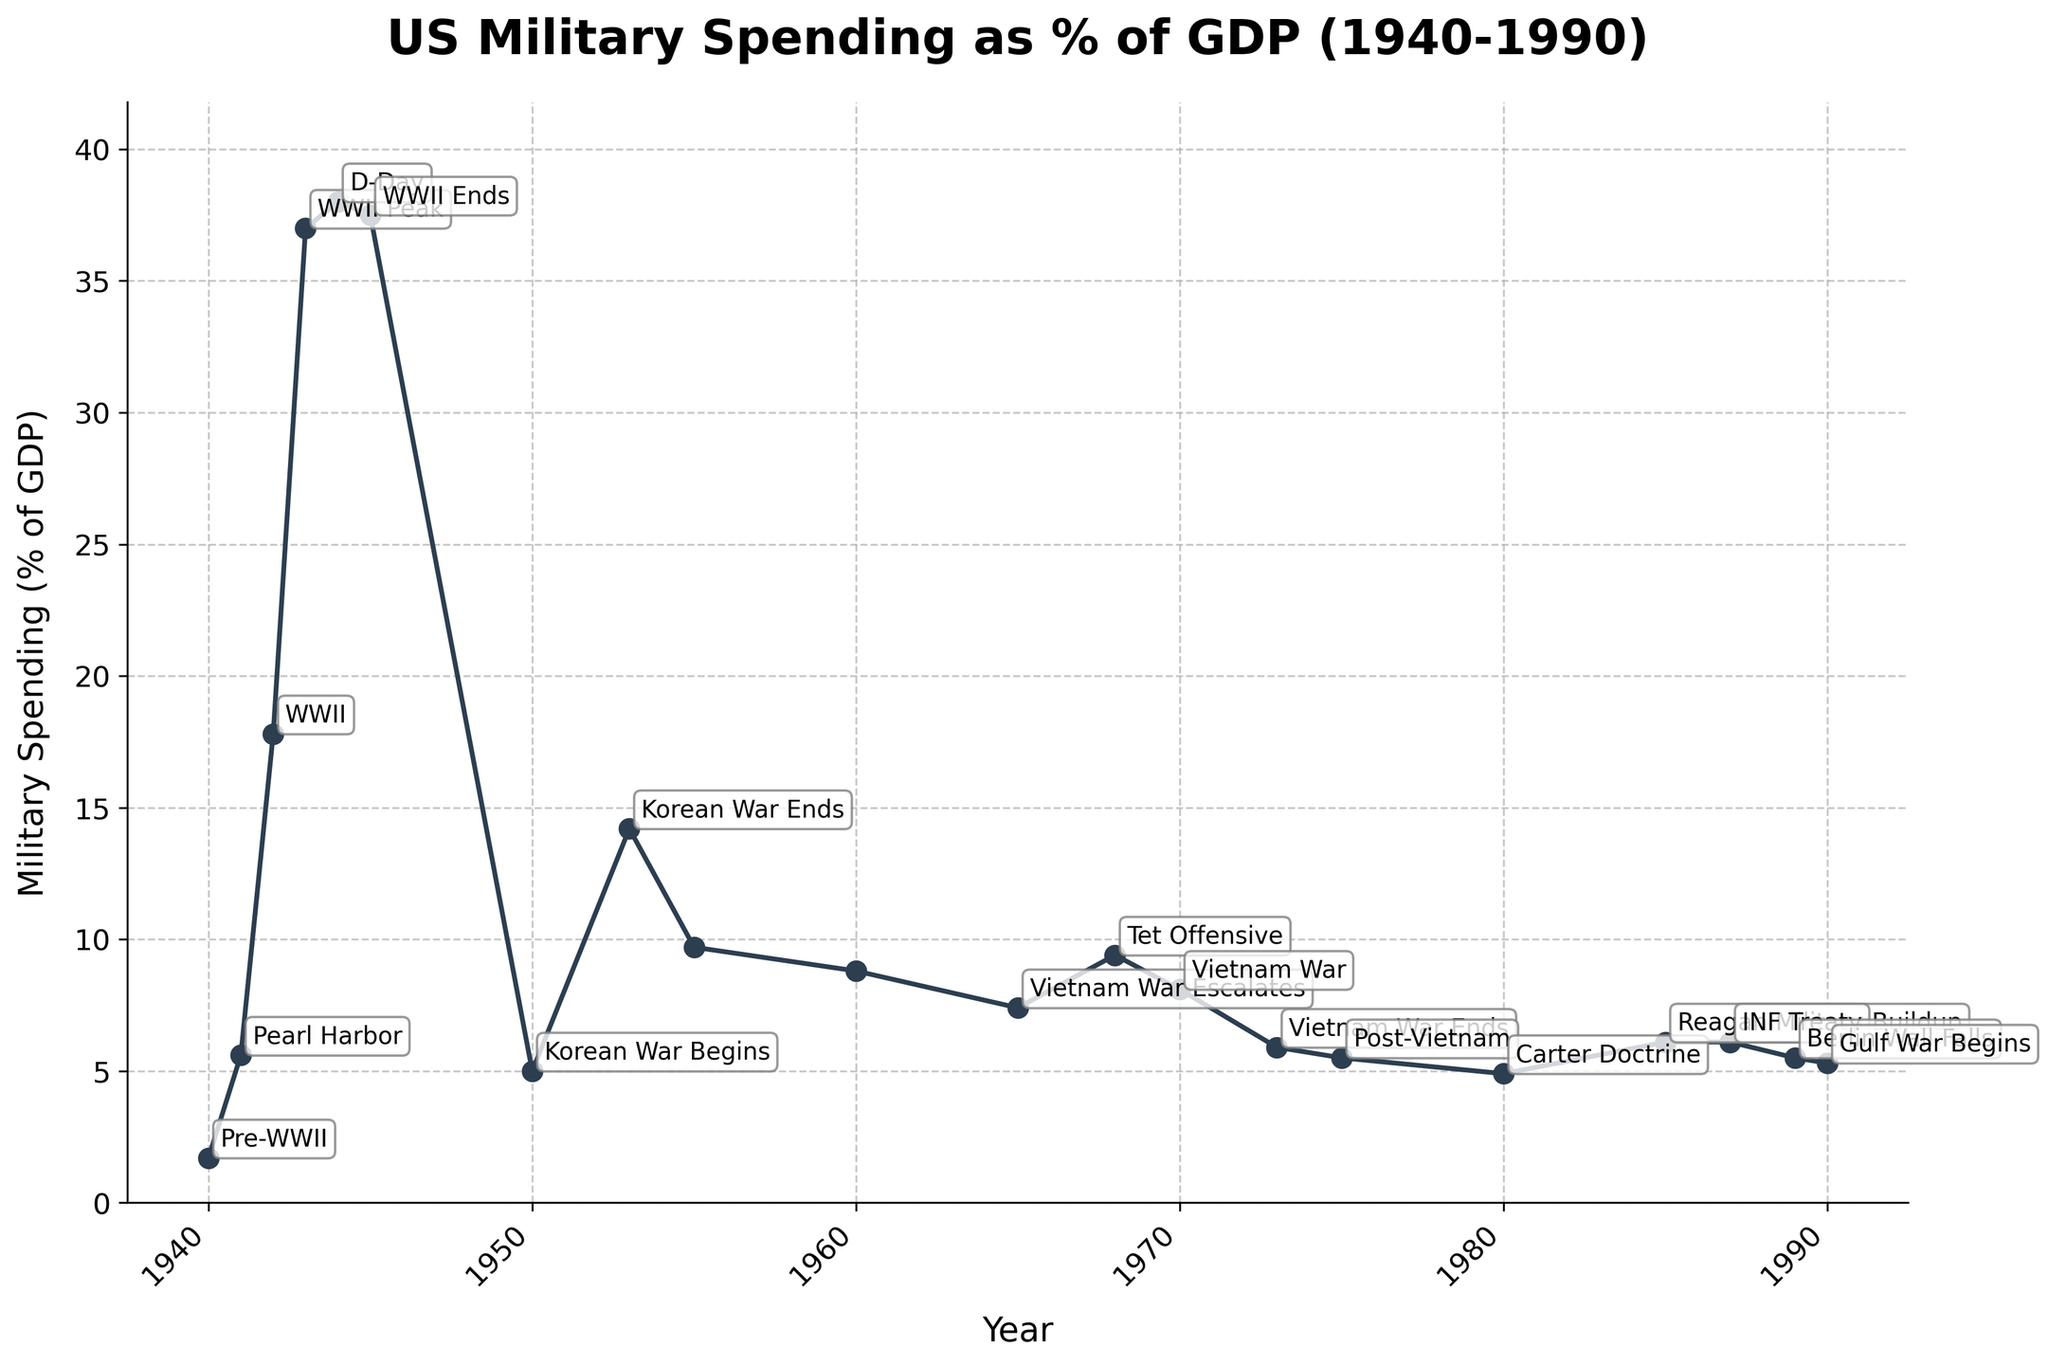What event marks the highest percentage of US military spending as a percentage of GDP? The highest percentage of US military spending as a percentage of GDP occurs during WWII Peak in 1943, marked at 38.0%. This can be seen as the highest point on the chart.
Answer: WWII Peak (38.0%) How does the military spending percentage change from the start to the end of WWII? At the start of WWII in 1941, military spending is 5.6% of GDP. By the end of WWII in 1945, it increases dramatically to 37.5% of GDP. The percentage rose by 31.9% ((37.5 - 5.6) = 31.9).
Answer: Increases by 31.9% Compare the military spending percentage during the beginning and the end of the Korean War. At the beginning of the Korean War in 1950, military spending is 5.0% of GDP. At the end in 1953, it rises to 14.2%. The spending increased by 9.2% ((14.2 - 5.0) = 9.2).
Answer: 9.2% What visual feature marks the period with the least military spending as a percentage of GDP? The lowest percentage of military spending can be visually identified as the smallest peak or dip in the plot, which is in 1980 at 4.9%.
Answer: 1980 at 4.9% Which event marks the beginning of a period of sustained higher military spending during the Cold War era? Observing the chart, the period of sustained higher military spending begins around Carter Doctrine (1980) through the Reagan Military Buildup (1985).
Answer: Carter Doctrine (1980) Calculate the average military spending percentage from 1955 to 1965. From 1955 to 1965, the values are 9.7%, 8.8%, and 7.4%. The average is calculated as (9.7 + 8.8 + 7.4) / 3 = 8.63%.
Answer: 8.63% Compare military spending as a percentage of GDP during the height of the Vietnam War and the Reagan Military Buildup. During the Tet Offensive in 1968, the percentage is 9.4%. During the Reagan Military Buildup in 1985, it is 6.1%. The spending was higher in 1968 by 3.3% ((9.4 - 6.1) = 3.3).
Answer: Higher by 3.3% What is the trend in military spending percentage after the fall of the Berlin Wall? After the fall of the Berlin Wall in 1989, military spending percentage declines from 5.5% in 1989 to 5.3% in 1990. This reflects a slight downward trend.
Answer: Slight decline How does the military spending percentage during WWII compare to the Korean War at their respective peaks? At the peak of WWII in 1944, military spending was 38.0% of GDP. The peak during the Korean War in 1953 was 14.2%. Comparing the two, WWII spending was significantly higher by 23.8% ((38.0 - 14.2) = 23.8).
Answer: WWII higher by 23.8% What color is used for the line representing US military spending as a percentage of GDP? The line representing US military spending as a percentage of GDP is colored in a dark shade, specifically a navy blue (as described as #2C3E50 in the code).
Answer: Navy blue 